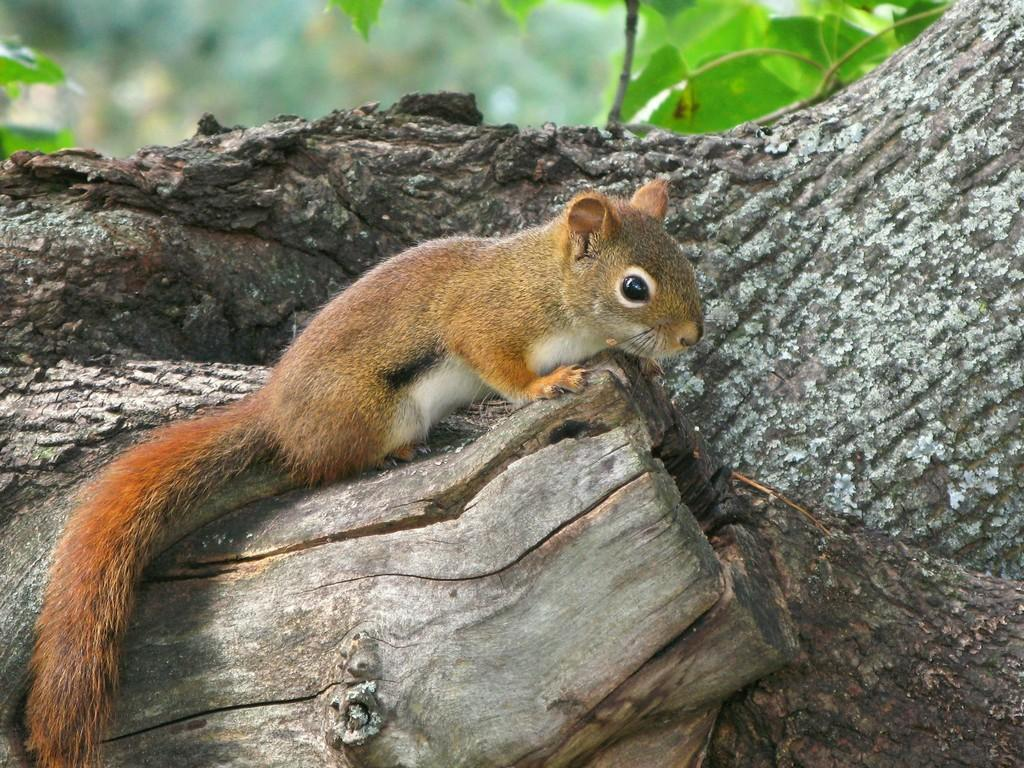What type of animal is in the image? There is a brown squirrel in the image. Where is the squirrel located? The squirrel is standing on a tree trunk. What can be seen in the background of the image? There are leaves visible in the image. How would you describe the overall focus of the image? The background of the image is slightly blurred. What type of spark can be seen coming from the squirrel's tail in the image? There is no spark visible in the image; it is a brown squirrel standing on a tree trunk with leaves in the background. 